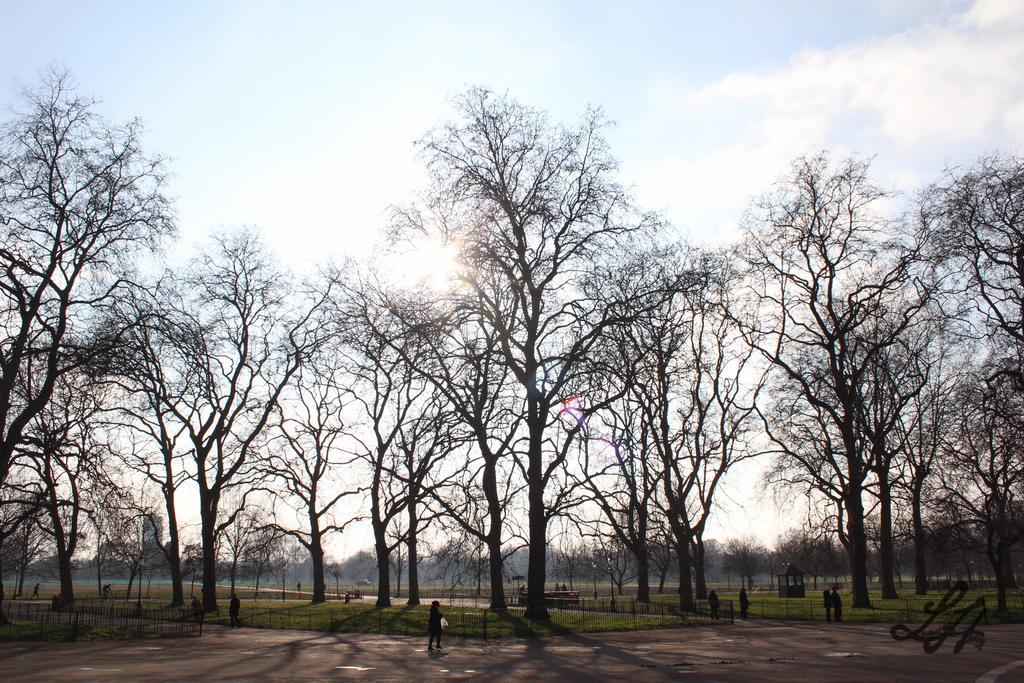Could you give a brief overview of what you see in this image? In this picture we can see group of people and few trees, and also we can see fence, at the right bottom of the image we can see a watermark. 